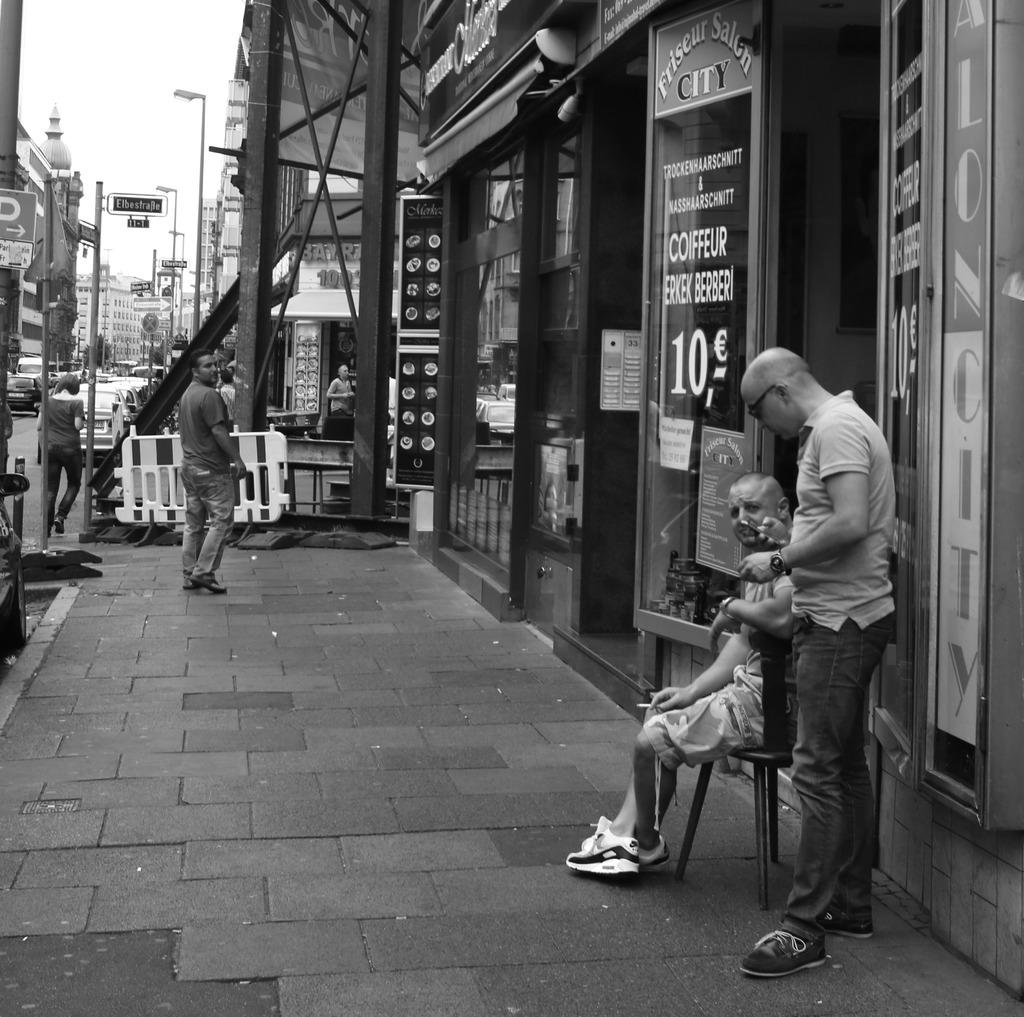What type of structures can be seen in the image? There are buildings in the image. Who or what else is present in the image? There are people in the image. What objects can be seen in the image that are used for displaying information or advertisements? There are boards in the image. What can be seen in the image that provides illumination? There are lights in the image. What type of vertical structures are present in the image? There are poles in the image. What is visible in the background of the image? The background of the image includes ksi. What type of pickle is being used to water the plants in the image? There is no pickle present in the image, nor are there any plants being watered. How does the feeling of the people in the image change throughout the day? The image does not convey the feelings of the people, so it cannot be determined how their feelings change throughout the day. 